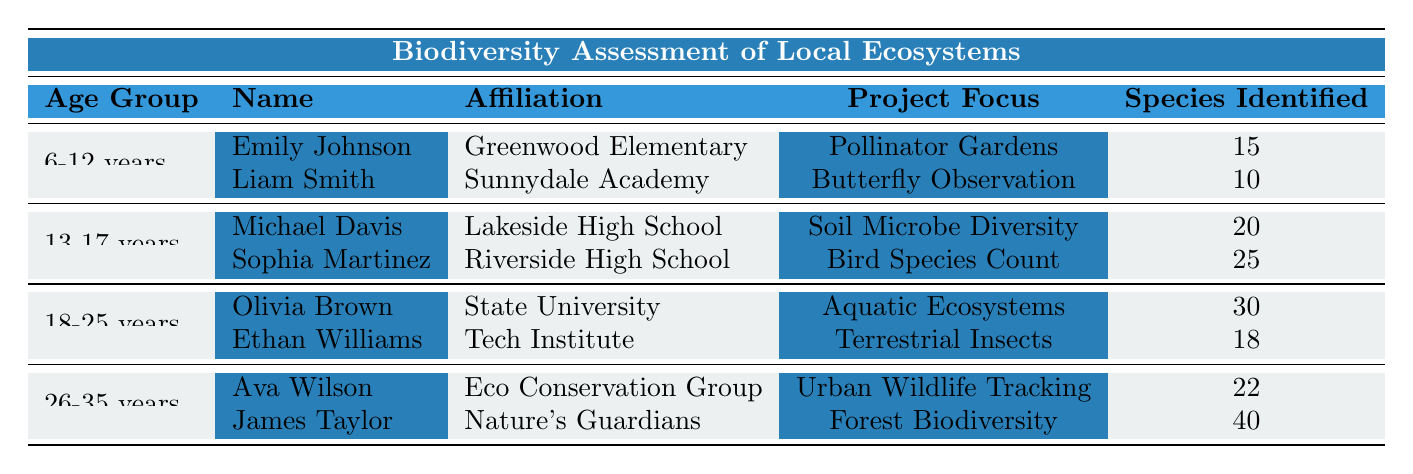What is the total number of species identified by participants aged 6-12 years? Emily Johnson identified 15 species and Liam Smith identified 10 species. Summing these gives a total of 15 + 10 = 25 species.
Answer: 25 Which project had the highest number of species identified? James Taylor's project, "Forest Biodiversity," identified 40 species, which is higher than any other project listed in the table.
Answer: Forest Biodiversity Did any participants focus on aquatic ecosystems? Yes, Olivia Brown focused on "Aquatic Ecosystems." This is confirmed in the table.
Answer: Yes What is the average number of species identified by participants in the 13-17 years age group? Michael Davis identified 20 species and Sophia Martinez identified 25 species. The average is (20 + 25) / 2 = 22.5 species.
Answer: 22.5 How many hours did the participants aged 26-35 years spend in total on their projects? Ava Wilson spent 12 hours and James Taylor spent 15 hours. Adding these gives 12 + 15 = 27 hours total.
Answer: 27 hours Is the total number of species identified by participants aged 18-25 years greater than that of participants aged 6-12 years? Participants aged 18-25 years identified a total of 30 + 18 = 48 species, while those aged 6-12 years identified 25 species. Since 48 > 25, this statement is true.
Answer: Yes Which age group had the participant that identified the lowest number of species? Liam Smith, in the 6-12 years age group, identified 10 species, which is the lowest compared to others.
Answer: 6-12 years What is the difference in time spent on projects between the participant who spent the most time and the one who spent the least across all age groups? James Taylor spent 15 hours and Emily Johnson spent 5 hours. The difference is 15 - 5 = 10 hours.
Answer: 10 hours How many more species were identified in total by participants aged 18-25 years compared to those aged 13-17 years? The 18-25 years age group's total is 30 + 18 = 48 species, while the 13-17 years age group's total is 20 + 25 = 45 species. Therefore, 48 - 45 = 3 more species were identified by the older age group.
Answer: 3 species Are there more participants in the 26-35 year age group compared to the 6-12 year age group? Both groups have 2 participants each, so they are equal.
Answer: No 